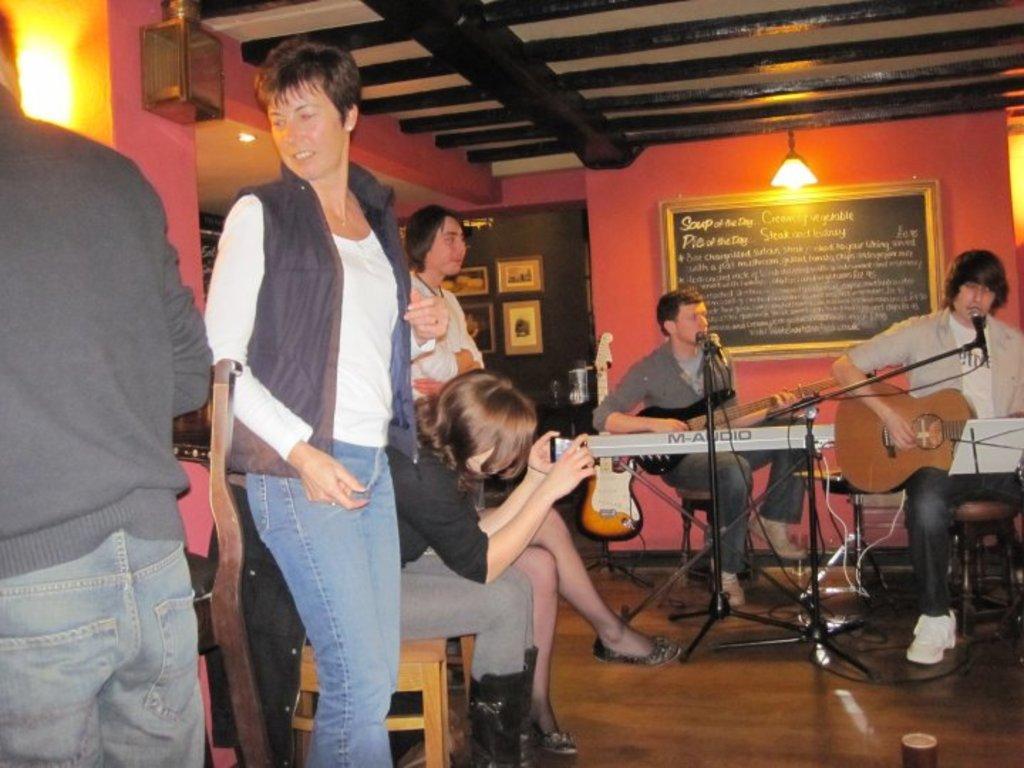Describe this image in one or two sentences. In the image there is a man playing guitar and singing on mic and beside him there is another guy also playing a guitar,in front there is a lady taking picture of them with cellphone and over the wall there is a bulb and below that there is board with text on it. There are few other people standing at the front left side. 